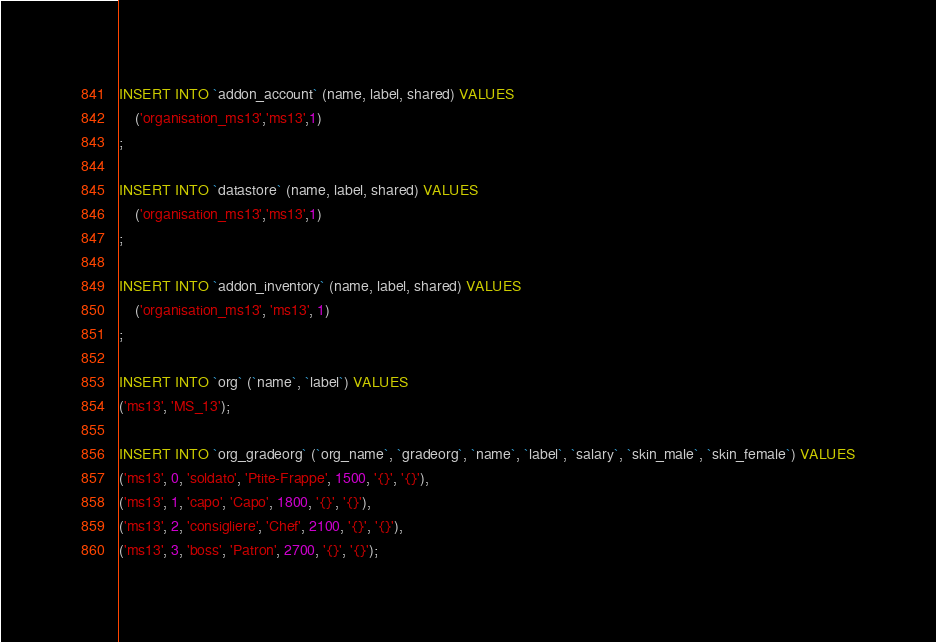Convert code to text. <code><loc_0><loc_0><loc_500><loc_500><_SQL_>INSERT INTO `addon_account` (name, label, shared) VALUES 
	('organisation_ms13','ms13',1)
;

INSERT INTO `datastore` (name, label, shared) VALUES 
	('organisation_ms13','ms13',1)
;

INSERT INTO `addon_inventory` (name, label, shared) VALUES 
	('organisation_ms13', 'ms13', 1)
;

INSERT INTO `org` (`name`, `label`) VALUES
('ms13', 'MS_13');

INSERT INTO `org_gradeorg` (`org_name`, `gradeorg`, `name`, `label`, `salary`, `skin_male`, `skin_female`) VALUES
('ms13', 0, 'soldato', 'Ptite-Frappe', 1500, '{}', '{}'),
('ms13', 1, 'capo', 'Capo', 1800, '{}', '{}'),
('ms13', 2, 'consigliere', 'Chef', 2100, '{}', '{}'),
('ms13', 3, 'boss', 'Patron', 2700, '{}', '{}');
</code> 